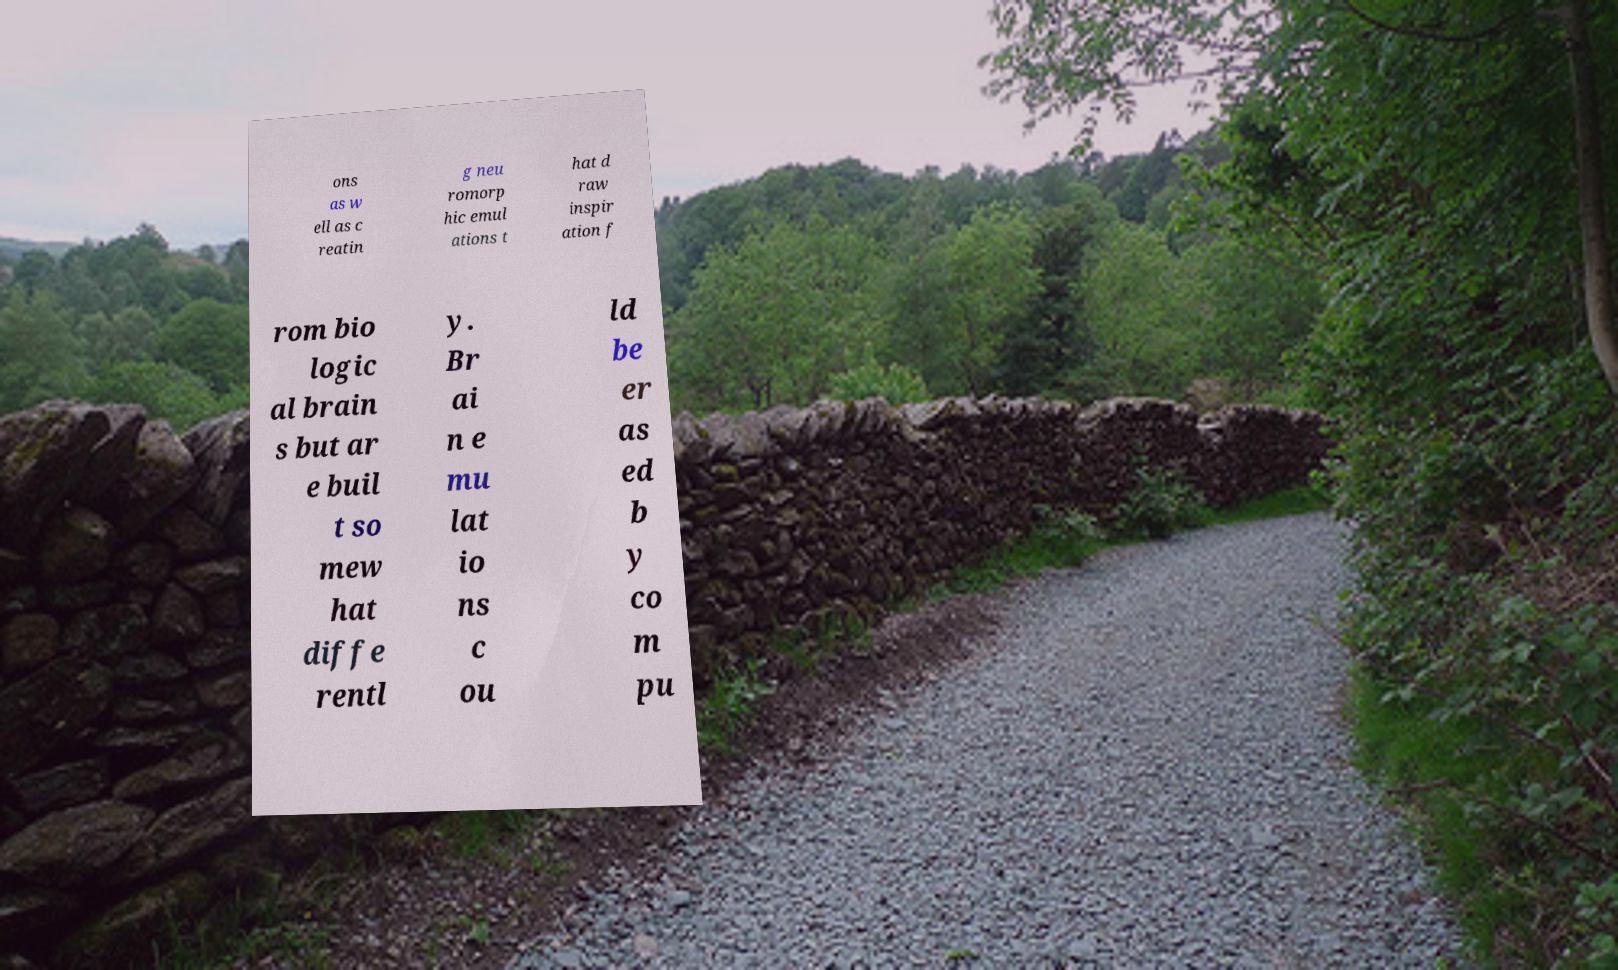Please read and relay the text visible in this image. What does it say? ons as w ell as c reatin g neu romorp hic emul ations t hat d raw inspir ation f rom bio logic al brain s but ar e buil t so mew hat diffe rentl y. Br ai n e mu lat io ns c ou ld be er as ed b y co m pu 